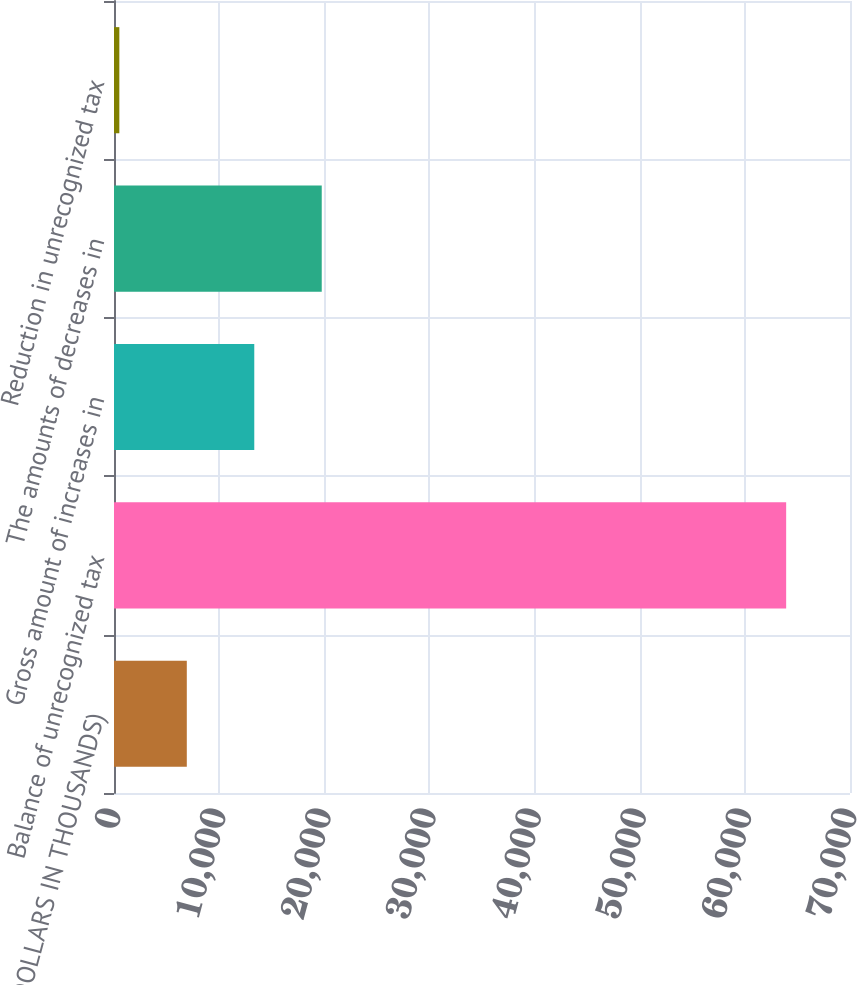<chart> <loc_0><loc_0><loc_500><loc_500><bar_chart><fcel>(DOLLARS IN THOUSANDS)<fcel>Balance of unrecognized tax<fcel>Gross amount of increases in<fcel>The amounts of decreases in<fcel>Reduction in unrecognized tax<nl><fcel>6924.5<fcel>63928<fcel>13341<fcel>19757.5<fcel>508<nl></chart> 